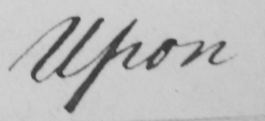Please transcribe the handwritten text in this image. Upon 